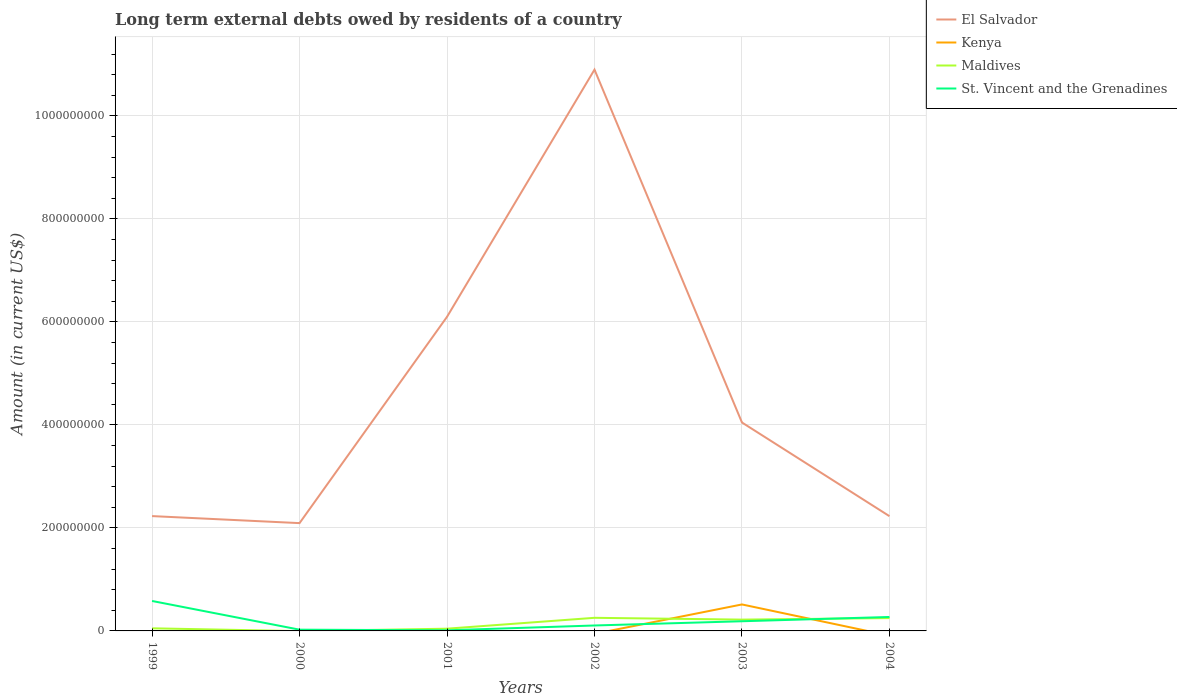How many different coloured lines are there?
Your answer should be compact. 4. Across all years, what is the maximum amount of long-term external debts owed by residents in St. Vincent and the Grenadines?
Keep it short and to the point. 1.21e+06. What is the total amount of long-term external debts owed by residents in El Salvador in the graph?
Keep it short and to the point. 1.41e+05. What is the difference between the highest and the second highest amount of long-term external debts owed by residents in El Salvador?
Offer a terse response. 8.80e+08. Is the amount of long-term external debts owed by residents in Kenya strictly greater than the amount of long-term external debts owed by residents in St. Vincent and the Grenadines over the years?
Provide a succinct answer. No. How many years are there in the graph?
Give a very brief answer. 6. Are the values on the major ticks of Y-axis written in scientific E-notation?
Give a very brief answer. No. Where does the legend appear in the graph?
Provide a short and direct response. Top right. How many legend labels are there?
Provide a short and direct response. 4. What is the title of the graph?
Offer a terse response. Long term external debts owed by residents of a country. Does "Czech Republic" appear as one of the legend labels in the graph?
Your response must be concise. No. What is the label or title of the X-axis?
Your answer should be compact. Years. What is the label or title of the Y-axis?
Offer a very short reply. Amount (in current US$). What is the Amount (in current US$) in El Salvador in 1999?
Provide a succinct answer. 2.23e+08. What is the Amount (in current US$) of Kenya in 1999?
Ensure brevity in your answer.  0. What is the Amount (in current US$) in Maldives in 1999?
Make the answer very short. 5.05e+06. What is the Amount (in current US$) in St. Vincent and the Grenadines in 1999?
Offer a terse response. 5.81e+07. What is the Amount (in current US$) in El Salvador in 2000?
Give a very brief answer. 2.09e+08. What is the Amount (in current US$) in Kenya in 2000?
Your answer should be compact. 0. What is the Amount (in current US$) in Maldives in 2000?
Provide a short and direct response. 0. What is the Amount (in current US$) of St. Vincent and the Grenadines in 2000?
Keep it short and to the point. 2.42e+06. What is the Amount (in current US$) of El Salvador in 2001?
Provide a short and direct response. 6.10e+08. What is the Amount (in current US$) in Kenya in 2001?
Give a very brief answer. 0. What is the Amount (in current US$) of Maldives in 2001?
Your answer should be compact. 4.34e+06. What is the Amount (in current US$) of St. Vincent and the Grenadines in 2001?
Offer a terse response. 1.21e+06. What is the Amount (in current US$) in El Salvador in 2002?
Your response must be concise. 1.09e+09. What is the Amount (in current US$) in Maldives in 2002?
Provide a succinct answer. 2.55e+07. What is the Amount (in current US$) in St. Vincent and the Grenadines in 2002?
Offer a very short reply. 1.05e+07. What is the Amount (in current US$) of El Salvador in 2003?
Provide a short and direct response. 4.05e+08. What is the Amount (in current US$) of Kenya in 2003?
Give a very brief answer. 5.14e+07. What is the Amount (in current US$) of Maldives in 2003?
Provide a short and direct response. 2.20e+07. What is the Amount (in current US$) in St. Vincent and the Grenadines in 2003?
Make the answer very short. 1.88e+07. What is the Amount (in current US$) in El Salvador in 2004?
Provide a short and direct response. 2.23e+08. What is the Amount (in current US$) in Kenya in 2004?
Keep it short and to the point. 0. What is the Amount (in current US$) of Maldives in 2004?
Make the answer very short. 2.49e+07. What is the Amount (in current US$) in St. Vincent and the Grenadines in 2004?
Keep it short and to the point. 2.71e+07. Across all years, what is the maximum Amount (in current US$) of El Salvador?
Ensure brevity in your answer.  1.09e+09. Across all years, what is the maximum Amount (in current US$) in Kenya?
Your answer should be compact. 5.14e+07. Across all years, what is the maximum Amount (in current US$) in Maldives?
Make the answer very short. 2.55e+07. Across all years, what is the maximum Amount (in current US$) of St. Vincent and the Grenadines?
Offer a terse response. 5.81e+07. Across all years, what is the minimum Amount (in current US$) in El Salvador?
Your response must be concise. 2.09e+08. Across all years, what is the minimum Amount (in current US$) in Maldives?
Your answer should be compact. 0. Across all years, what is the minimum Amount (in current US$) in St. Vincent and the Grenadines?
Ensure brevity in your answer.  1.21e+06. What is the total Amount (in current US$) of El Salvador in the graph?
Your response must be concise. 2.76e+09. What is the total Amount (in current US$) in Kenya in the graph?
Ensure brevity in your answer.  5.14e+07. What is the total Amount (in current US$) of Maldives in the graph?
Offer a terse response. 8.17e+07. What is the total Amount (in current US$) in St. Vincent and the Grenadines in the graph?
Ensure brevity in your answer.  1.18e+08. What is the difference between the Amount (in current US$) in El Salvador in 1999 and that in 2000?
Keep it short and to the point. 1.37e+07. What is the difference between the Amount (in current US$) in St. Vincent and the Grenadines in 1999 and that in 2000?
Make the answer very short. 5.57e+07. What is the difference between the Amount (in current US$) of El Salvador in 1999 and that in 2001?
Your answer should be compact. -3.87e+08. What is the difference between the Amount (in current US$) of Maldives in 1999 and that in 2001?
Give a very brief answer. 7.08e+05. What is the difference between the Amount (in current US$) in St. Vincent and the Grenadines in 1999 and that in 2001?
Make the answer very short. 5.69e+07. What is the difference between the Amount (in current US$) in El Salvador in 1999 and that in 2002?
Your answer should be compact. -8.67e+08. What is the difference between the Amount (in current US$) of Maldives in 1999 and that in 2002?
Ensure brevity in your answer.  -2.04e+07. What is the difference between the Amount (in current US$) in St. Vincent and the Grenadines in 1999 and that in 2002?
Your answer should be very brief. 4.76e+07. What is the difference between the Amount (in current US$) in El Salvador in 1999 and that in 2003?
Your answer should be compact. -1.82e+08. What is the difference between the Amount (in current US$) in Maldives in 1999 and that in 2003?
Give a very brief answer. -1.69e+07. What is the difference between the Amount (in current US$) of St. Vincent and the Grenadines in 1999 and that in 2003?
Offer a terse response. 3.94e+07. What is the difference between the Amount (in current US$) in El Salvador in 1999 and that in 2004?
Give a very brief answer. 1.41e+05. What is the difference between the Amount (in current US$) in Maldives in 1999 and that in 2004?
Provide a short and direct response. -1.98e+07. What is the difference between the Amount (in current US$) in St. Vincent and the Grenadines in 1999 and that in 2004?
Give a very brief answer. 3.11e+07. What is the difference between the Amount (in current US$) in El Salvador in 2000 and that in 2001?
Provide a succinct answer. -4.01e+08. What is the difference between the Amount (in current US$) of St. Vincent and the Grenadines in 2000 and that in 2001?
Ensure brevity in your answer.  1.20e+06. What is the difference between the Amount (in current US$) in El Salvador in 2000 and that in 2002?
Make the answer very short. -8.80e+08. What is the difference between the Amount (in current US$) in St. Vincent and the Grenadines in 2000 and that in 2002?
Your answer should be very brief. -8.13e+06. What is the difference between the Amount (in current US$) of El Salvador in 2000 and that in 2003?
Offer a very short reply. -1.95e+08. What is the difference between the Amount (in current US$) of St. Vincent and the Grenadines in 2000 and that in 2003?
Your response must be concise. -1.64e+07. What is the difference between the Amount (in current US$) in El Salvador in 2000 and that in 2004?
Ensure brevity in your answer.  -1.35e+07. What is the difference between the Amount (in current US$) of St. Vincent and the Grenadines in 2000 and that in 2004?
Make the answer very short. -2.47e+07. What is the difference between the Amount (in current US$) of El Salvador in 2001 and that in 2002?
Make the answer very short. -4.80e+08. What is the difference between the Amount (in current US$) in Maldives in 2001 and that in 2002?
Provide a short and direct response. -2.11e+07. What is the difference between the Amount (in current US$) of St. Vincent and the Grenadines in 2001 and that in 2002?
Provide a short and direct response. -9.33e+06. What is the difference between the Amount (in current US$) of El Salvador in 2001 and that in 2003?
Your response must be concise. 2.05e+08. What is the difference between the Amount (in current US$) of Maldives in 2001 and that in 2003?
Your answer should be compact. -1.76e+07. What is the difference between the Amount (in current US$) of St. Vincent and the Grenadines in 2001 and that in 2003?
Offer a terse response. -1.76e+07. What is the difference between the Amount (in current US$) in El Salvador in 2001 and that in 2004?
Make the answer very short. 3.87e+08. What is the difference between the Amount (in current US$) of Maldives in 2001 and that in 2004?
Offer a very short reply. -2.05e+07. What is the difference between the Amount (in current US$) of St. Vincent and the Grenadines in 2001 and that in 2004?
Provide a succinct answer. -2.59e+07. What is the difference between the Amount (in current US$) of El Salvador in 2002 and that in 2003?
Offer a very short reply. 6.85e+08. What is the difference between the Amount (in current US$) in Maldives in 2002 and that in 2003?
Your answer should be compact. 3.50e+06. What is the difference between the Amount (in current US$) in St. Vincent and the Grenadines in 2002 and that in 2003?
Make the answer very short. -8.23e+06. What is the difference between the Amount (in current US$) in El Salvador in 2002 and that in 2004?
Offer a terse response. 8.67e+08. What is the difference between the Amount (in current US$) in Maldives in 2002 and that in 2004?
Keep it short and to the point. 5.66e+05. What is the difference between the Amount (in current US$) of St. Vincent and the Grenadines in 2002 and that in 2004?
Give a very brief answer. -1.65e+07. What is the difference between the Amount (in current US$) of El Salvador in 2003 and that in 2004?
Offer a terse response. 1.82e+08. What is the difference between the Amount (in current US$) of Maldives in 2003 and that in 2004?
Your response must be concise. -2.94e+06. What is the difference between the Amount (in current US$) of St. Vincent and the Grenadines in 2003 and that in 2004?
Ensure brevity in your answer.  -8.30e+06. What is the difference between the Amount (in current US$) in El Salvador in 1999 and the Amount (in current US$) in St. Vincent and the Grenadines in 2000?
Your response must be concise. 2.21e+08. What is the difference between the Amount (in current US$) of Maldives in 1999 and the Amount (in current US$) of St. Vincent and the Grenadines in 2000?
Keep it short and to the point. 2.64e+06. What is the difference between the Amount (in current US$) of El Salvador in 1999 and the Amount (in current US$) of Maldives in 2001?
Your answer should be compact. 2.19e+08. What is the difference between the Amount (in current US$) in El Salvador in 1999 and the Amount (in current US$) in St. Vincent and the Grenadines in 2001?
Offer a very short reply. 2.22e+08. What is the difference between the Amount (in current US$) in Maldives in 1999 and the Amount (in current US$) in St. Vincent and the Grenadines in 2001?
Provide a short and direct response. 3.84e+06. What is the difference between the Amount (in current US$) of El Salvador in 1999 and the Amount (in current US$) of Maldives in 2002?
Your response must be concise. 1.97e+08. What is the difference between the Amount (in current US$) of El Salvador in 1999 and the Amount (in current US$) of St. Vincent and the Grenadines in 2002?
Make the answer very short. 2.12e+08. What is the difference between the Amount (in current US$) in Maldives in 1999 and the Amount (in current US$) in St. Vincent and the Grenadines in 2002?
Give a very brief answer. -5.49e+06. What is the difference between the Amount (in current US$) of El Salvador in 1999 and the Amount (in current US$) of Kenya in 2003?
Provide a succinct answer. 1.72e+08. What is the difference between the Amount (in current US$) in El Salvador in 1999 and the Amount (in current US$) in Maldives in 2003?
Your answer should be compact. 2.01e+08. What is the difference between the Amount (in current US$) in El Salvador in 1999 and the Amount (in current US$) in St. Vincent and the Grenadines in 2003?
Your response must be concise. 2.04e+08. What is the difference between the Amount (in current US$) in Maldives in 1999 and the Amount (in current US$) in St. Vincent and the Grenadines in 2003?
Your answer should be very brief. -1.37e+07. What is the difference between the Amount (in current US$) of El Salvador in 1999 and the Amount (in current US$) of Maldives in 2004?
Provide a short and direct response. 1.98e+08. What is the difference between the Amount (in current US$) of El Salvador in 1999 and the Amount (in current US$) of St. Vincent and the Grenadines in 2004?
Give a very brief answer. 1.96e+08. What is the difference between the Amount (in current US$) of Maldives in 1999 and the Amount (in current US$) of St. Vincent and the Grenadines in 2004?
Your response must be concise. -2.20e+07. What is the difference between the Amount (in current US$) of El Salvador in 2000 and the Amount (in current US$) of Maldives in 2001?
Provide a short and direct response. 2.05e+08. What is the difference between the Amount (in current US$) of El Salvador in 2000 and the Amount (in current US$) of St. Vincent and the Grenadines in 2001?
Offer a terse response. 2.08e+08. What is the difference between the Amount (in current US$) of El Salvador in 2000 and the Amount (in current US$) of Maldives in 2002?
Provide a succinct answer. 1.84e+08. What is the difference between the Amount (in current US$) of El Salvador in 2000 and the Amount (in current US$) of St. Vincent and the Grenadines in 2002?
Your answer should be very brief. 1.99e+08. What is the difference between the Amount (in current US$) of El Salvador in 2000 and the Amount (in current US$) of Kenya in 2003?
Your answer should be very brief. 1.58e+08. What is the difference between the Amount (in current US$) in El Salvador in 2000 and the Amount (in current US$) in Maldives in 2003?
Provide a short and direct response. 1.87e+08. What is the difference between the Amount (in current US$) of El Salvador in 2000 and the Amount (in current US$) of St. Vincent and the Grenadines in 2003?
Your answer should be very brief. 1.90e+08. What is the difference between the Amount (in current US$) in El Salvador in 2000 and the Amount (in current US$) in Maldives in 2004?
Keep it short and to the point. 1.84e+08. What is the difference between the Amount (in current US$) of El Salvador in 2000 and the Amount (in current US$) of St. Vincent and the Grenadines in 2004?
Offer a terse response. 1.82e+08. What is the difference between the Amount (in current US$) in El Salvador in 2001 and the Amount (in current US$) in Maldives in 2002?
Provide a short and direct response. 5.84e+08. What is the difference between the Amount (in current US$) of El Salvador in 2001 and the Amount (in current US$) of St. Vincent and the Grenadines in 2002?
Offer a very short reply. 5.99e+08. What is the difference between the Amount (in current US$) of Maldives in 2001 and the Amount (in current US$) of St. Vincent and the Grenadines in 2002?
Provide a succinct answer. -6.20e+06. What is the difference between the Amount (in current US$) in El Salvador in 2001 and the Amount (in current US$) in Kenya in 2003?
Give a very brief answer. 5.58e+08. What is the difference between the Amount (in current US$) of El Salvador in 2001 and the Amount (in current US$) of Maldives in 2003?
Your response must be concise. 5.88e+08. What is the difference between the Amount (in current US$) of El Salvador in 2001 and the Amount (in current US$) of St. Vincent and the Grenadines in 2003?
Ensure brevity in your answer.  5.91e+08. What is the difference between the Amount (in current US$) of Maldives in 2001 and the Amount (in current US$) of St. Vincent and the Grenadines in 2003?
Your answer should be very brief. -1.44e+07. What is the difference between the Amount (in current US$) of El Salvador in 2001 and the Amount (in current US$) of Maldives in 2004?
Keep it short and to the point. 5.85e+08. What is the difference between the Amount (in current US$) of El Salvador in 2001 and the Amount (in current US$) of St. Vincent and the Grenadines in 2004?
Offer a very short reply. 5.83e+08. What is the difference between the Amount (in current US$) in Maldives in 2001 and the Amount (in current US$) in St. Vincent and the Grenadines in 2004?
Your response must be concise. -2.27e+07. What is the difference between the Amount (in current US$) of El Salvador in 2002 and the Amount (in current US$) of Kenya in 2003?
Keep it short and to the point. 1.04e+09. What is the difference between the Amount (in current US$) of El Salvador in 2002 and the Amount (in current US$) of Maldives in 2003?
Provide a short and direct response. 1.07e+09. What is the difference between the Amount (in current US$) in El Salvador in 2002 and the Amount (in current US$) in St. Vincent and the Grenadines in 2003?
Your answer should be very brief. 1.07e+09. What is the difference between the Amount (in current US$) of Maldives in 2002 and the Amount (in current US$) of St. Vincent and the Grenadines in 2003?
Provide a succinct answer. 6.68e+06. What is the difference between the Amount (in current US$) in El Salvador in 2002 and the Amount (in current US$) in Maldives in 2004?
Keep it short and to the point. 1.06e+09. What is the difference between the Amount (in current US$) of El Salvador in 2002 and the Amount (in current US$) of St. Vincent and the Grenadines in 2004?
Provide a short and direct response. 1.06e+09. What is the difference between the Amount (in current US$) of Maldives in 2002 and the Amount (in current US$) of St. Vincent and the Grenadines in 2004?
Your response must be concise. -1.62e+06. What is the difference between the Amount (in current US$) in El Salvador in 2003 and the Amount (in current US$) in Maldives in 2004?
Your answer should be compact. 3.80e+08. What is the difference between the Amount (in current US$) of El Salvador in 2003 and the Amount (in current US$) of St. Vincent and the Grenadines in 2004?
Your answer should be very brief. 3.78e+08. What is the difference between the Amount (in current US$) of Kenya in 2003 and the Amount (in current US$) of Maldives in 2004?
Offer a terse response. 2.65e+07. What is the difference between the Amount (in current US$) of Kenya in 2003 and the Amount (in current US$) of St. Vincent and the Grenadines in 2004?
Ensure brevity in your answer.  2.43e+07. What is the difference between the Amount (in current US$) in Maldives in 2003 and the Amount (in current US$) in St. Vincent and the Grenadines in 2004?
Your answer should be very brief. -5.13e+06. What is the average Amount (in current US$) of El Salvador per year?
Make the answer very short. 4.60e+08. What is the average Amount (in current US$) of Kenya per year?
Make the answer very short. 8.57e+06. What is the average Amount (in current US$) of Maldives per year?
Offer a terse response. 1.36e+07. What is the average Amount (in current US$) in St. Vincent and the Grenadines per year?
Your answer should be very brief. 1.97e+07. In the year 1999, what is the difference between the Amount (in current US$) of El Salvador and Amount (in current US$) of Maldives?
Your answer should be compact. 2.18e+08. In the year 1999, what is the difference between the Amount (in current US$) of El Salvador and Amount (in current US$) of St. Vincent and the Grenadines?
Ensure brevity in your answer.  1.65e+08. In the year 1999, what is the difference between the Amount (in current US$) of Maldives and Amount (in current US$) of St. Vincent and the Grenadines?
Give a very brief answer. -5.31e+07. In the year 2000, what is the difference between the Amount (in current US$) of El Salvador and Amount (in current US$) of St. Vincent and the Grenadines?
Offer a terse response. 2.07e+08. In the year 2001, what is the difference between the Amount (in current US$) of El Salvador and Amount (in current US$) of Maldives?
Keep it short and to the point. 6.05e+08. In the year 2001, what is the difference between the Amount (in current US$) of El Salvador and Amount (in current US$) of St. Vincent and the Grenadines?
Give a very brief answer. 6.09e+08. In the year 2001, what is the difference between the Amount (in current US$) in Maldives and Amount (in current US$) in St. Vincent and the Grenadines?
Your response must be concise. 3.13e+06. In the year 2002, what is the difference between the Amount (in current US$) of El Salvador and Amount (in current US$) of Maldives?
Your answer should be compact. 1.06e+09. In the year 2002, what is the difference between the Amount (in current US$) of El Salvador and Amount (in current US$) of St. Vincent and the Grenadines?
Provide a succinct answer. 1.08e+09. In the year 2002, what is the difference between the Amount (in current US$) in Maldives and Amount (in current US$) in St. Vincent and the Grenadines?
Ensure brevity in your answer.  1.49e+07. In the year 2003, what is the difference between the Amount (in current US$) in El Salvador and Amount (in current US$) in Kenya?
Your response must be concise. 3.53e+08. In the year 2003, what is the difference between the Amount (in current US$) in El Salvador and Amount (in current US$) in Maldives?
Offer a very short reply. 3.83e+08. In the year 2003, what is the difference between the Amount (in current US$) in El Salvador and Amount (in current US$) in St. Vincent and the Grenadines?
Provide a short and direct response. 3.86e+08. In the year 2003, what is the difference between the Amount (in current US$) of Kenya and Amount (in current US$) of Maldives?
Your answer should be very brief. 2.94e+07. In the year 2003, what is the difference between the Amount (in current US$) in Kenya and Amount (in current US$) in St. Vincent and the Grenadines?
Offer a very short reply. 3.26e+07. In the year 2003, what is the difference between the Amount (in current US$) in Maldives and Amount (in current US$) in St. Vincent and the Grenadines?
Offer a very short reply. 3.18e+06. In the year 2004, what is the difference between the Amount (in current US$) of El Salvador and Amount (in current US$) of Maldives?
Keep it short and to the point. 1.98e+08. In the year 2004, what is the difference between the Amount (in current US$) of El Salvador and Amount (in current US$) of St. Vincent and the Grenadines?
Your answer should be compact. 1.96e+08. In the year 2004, what is the difference between the Amount (in current US$) of Maldives and Amount (in current US$) of St. Vincent and the Grenadines?
Keep it short and to the point. -2.19e+06. What is the ratio of the Amount (in current US$) in El Salvador in 1999 to that in 2000?
Give a very brief answer. 1.07. What is the ratio of the Amount (in current US$) in St. Vincent and the Grenadines in 1999 to that in 2000?
Give a very brief answer. 24.06. What is the ratio of the Amount (in current US$) of El Salvador in 1999 to that in 2001?
Ensure brevity in your answer.  0.37. What is the ratio of the Amount (in current US$) of Maldives in 1999 to that in 2001?
Offer a terse response. 1.16. What is the ratio of the Amount (in current US$) of St. Vincent and the Grenadines in 1999 to that in 2001?
Provide a succinct answer. 47.94. What is the ratio of the Amount (in current US$) of El Salvador in 1999 to that in 2002?
Make the answer very short. 0.2. What is the ratio of the Amount (in current US$) of Maldives in 1999 to that in 2002?
Your response must be concise. 0.2. What is the ratio of the Amount (in current US$) in St. Vincent and the Grenadines in 1999 to that in 2002?
Your response must be concise. 5.51. What is the ratio of the Amount (in current US$) of El Salvador in 1999 to that in 2003?
Offer a terse response. 0.55. What is the ratio of the Amount (in current US$) of Maldives in 1999 to that in 2003?
Ensure brevity in your answer.  0.23. What is the ratio of the Amount (in current US$) of St. Vincent and the Grenadines in 1999 to that in 2003?
Keep it short and to the point. 3.1. What is the ratio of the Amount (in current US$) of Maldives in 1999 to that in 2004?
Offer a very short reply. 0.2. What is the ratio of the Amount (in current US$) of St. Vincent and the Grenadines in 1999 to that in 2004?
Offer a terse response. 2.15. What is the ratio of the Amount (in current US$) in El Salvador in 2000 to that in 2001?
Give a very brief answer. 0.34. What is the ratio of the Amount (in current US$) of St. Vincent and the Grenadines in 2000 to that in 2001?
Provide a short and direct response. 1.99. What is the ratio of the Amount (in current US$) in El Salvador in 2000 to that in 2002?
Give a very brief answer. 0.19. What is the ratio of the Amount (in current US$) of St. Vincent and the Grenadines in 2000 to that in 2002?
Provide a succinct answer. 0.23. What is the ratio of the Amount (in current US$) of El Salvador in 2000 to that in 2003?
Your answer should be very brief. 0.52. What is the ratio of the Amount (in current US$) of St. Vincent and the Grenadines in 2000 to that in 2003?
Give a very brief answer. 0.13. What is the ratio of the Amount (in current US$) in El Salvador in 2000 to that in 2004?
Provide a short and direct response. 0.94. What is the ratio of the Amount (in current US$) of St. Vincent and the Grenadines in 2000 to that in 2004?
Offer a very short reply. 0.09. What is the ratio of the Amount (in current US$) in El Salvador in 2001 to that in 2002?
Provide a succinct answer. 0.56. What is the ratio of the Amount (in current US$) of Maldives in 2001 to that in 2002?
Offer a very short reply. 0.17. What is the ratio of the Amount (in current US$) of St. Vincent and the Grenadines in 2001 to that in 2002?
Provide a succinct answer. 0.12. What is the ratio of the Amount (in current US$) in El Salvador in 2001 to that in 2003?
Your answer should be very brief. 1.51. What is the ratio of the Amount (in current US$) of Maldives in 2001 to that in 2003?
Keep it short and to the point. 0.2. What is the ratio of the Amount (in current US$) in St. Vincent and the Grenadines in 2001 to that in 2003?
Make the answer very short. 0.06. What is the ratio of the Amount (in current US$) of El Salvador in 2001 to that in 2004?
Give a very brief answer. 2.74. What is the ratio of the Amount (in current US$) in Maldives in 2001 to that in 2004?
Keep it short and to the point. 0.17. What is the ratio of the Amount (in current US$) of St. Vincent and the Grenadines in 2001 to that in 2004?
Your answer should be compact. 0.04. What is the ratio of the Amount (in current US$) in El Salvador in 2002 to that in 2003?
Your answer should be very brief. 2.69. What is the ratio of the Amount (in current US$) in Maldives in 2002 to that in 2003?
Offer a terse response. 1.16. What is the ratio of the Amount (in current US$) in St. Vincent and the Grenadines in 2002 to that in 2003?
Keep it short and to the point. 0.56. What is the ratio of the Amount (in current US$) of El Salvador in 2002 to that in 2004?
Provide a succinct answer. 4.89. What is the ratio of the Amount (in current US$) of Maldives in 2002 to that in 2004?
Ensure brevity in your answer.  1.02. What is the ratio of the Amount (in current US$) of St. Vincent and the Grenadines in 2002 to that in 2004?
Provide a succinct answer. 0.39. What is the ratio of the Amount (in current US$) in El Salvador in 2003 to that in 2004?
Give a very brief answer. 1.82. What is the ratio of the Amount (in current US$) in Maldives in 2003 to that in 2004?
Your response must be concise. 0.88. What is the ratio of the Amount (in current US$) in St. Vincent and the Grenadines in 2003 to that in 2004?
Offer a very short reply. 0.69. What is the difference between the highest and the second highest Amount (in current US$) of El Salvador?
Offer a terse response. 4.80e+08. What is the difference between the highest and the second highest Amount (in current US$) in Maldives?
Provide a succinct answer. 5.66e+05. What is the difference between the highest and the second highest Amount (in current US$) in St. Vincent and the Grenadines?
Your answer should be very brief. 3.11e+07. What is the difference between the highest and the lowest Amount (in current US$) of El Salvador?
Offer a very short reply. 8.80e+08. What is the difference between the highest and the lowest Amount (in current US$) in Kenya?
Ensure brevity in your answer.  5.14e+07. What is the difference between the highest and the lowest Amount (in current US$) of Maldives?
Your answer should be compact. 2.55e+07. What is the difference between the highest and the lowest Amount (in current US$) in St. Vincent and the Grenadines?
Provide a short and direct response. 5.69e+07. 